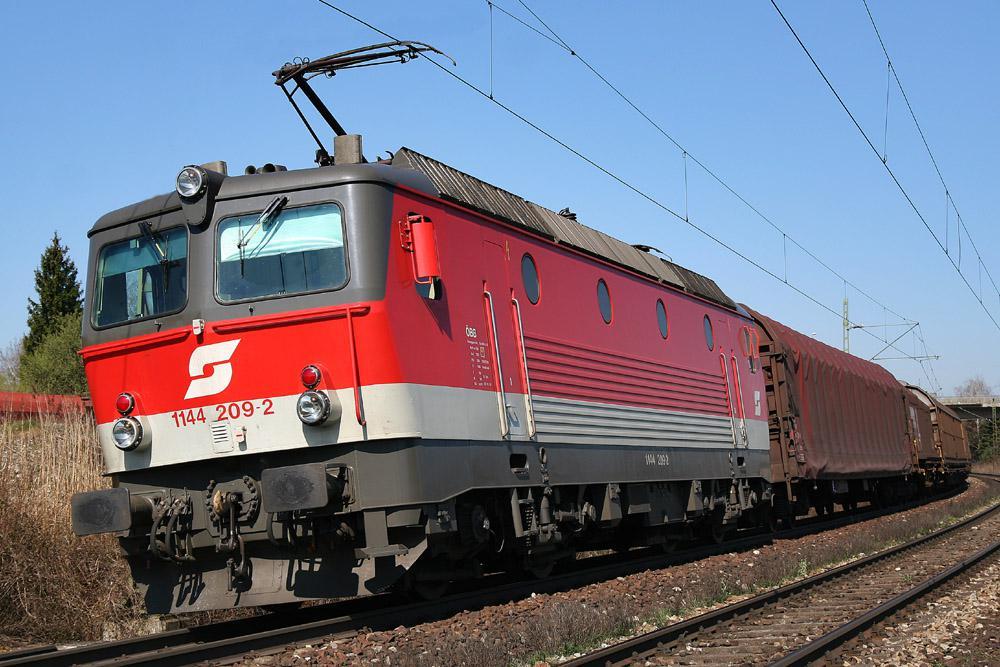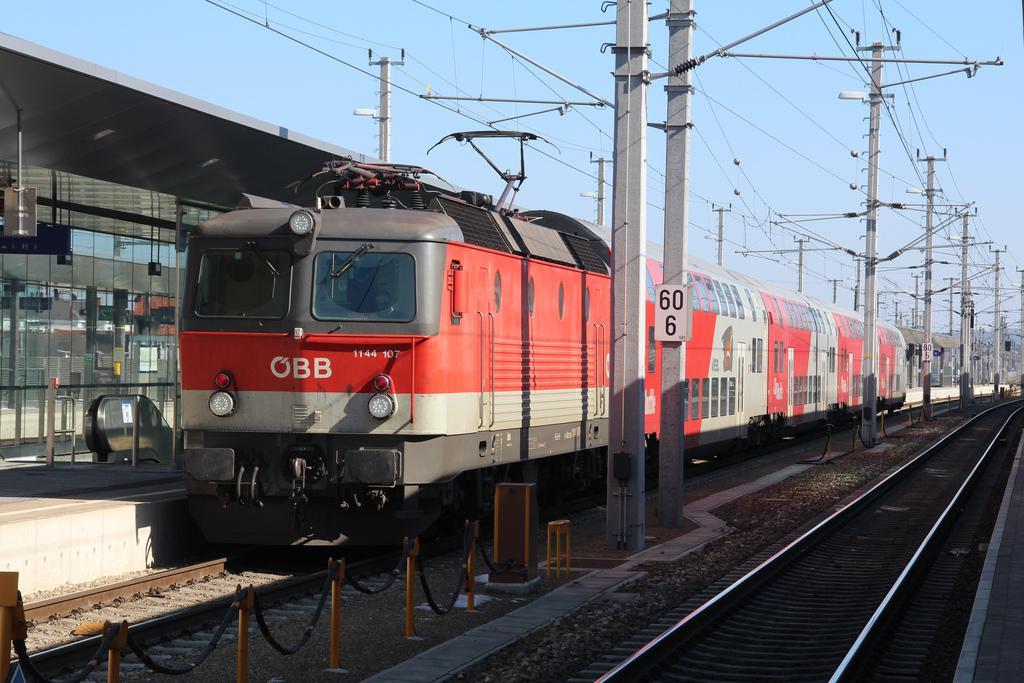The first image is the image on the left, the second image is the image on the right. For the images displayed, is the sentence "One image shows a leftward headed train, and the other shows a rightward angled train." factually correct? Answer yes or no. No. The first image is the image on the left, the second image is the image on the right. Evaluate the accuracy of this statement regarding the images: "Both trains are pointed in the same direction.". Is it true? Answer yes or no. Yes. 